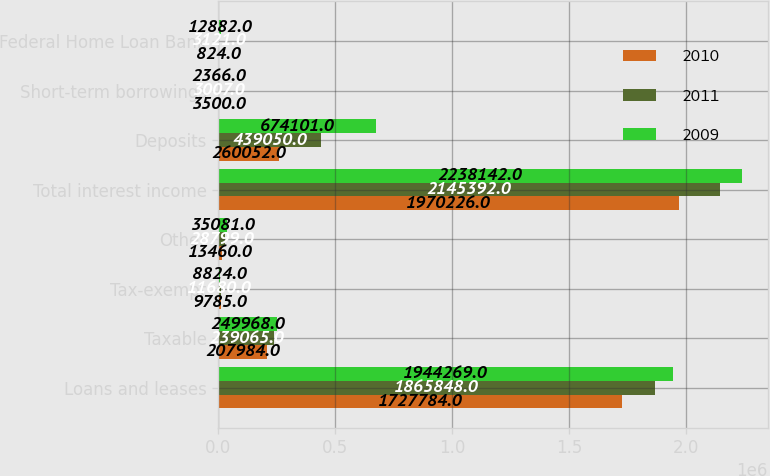Convert chart. <chart><loc_0><loc_0><loc_500><loc_500><stacked_bar_chart><ecel><fcel>Loans and leases<fcel>Taxable<fcel>Tax-exempt<fcel>Other<fcel>Total interest income<fcel>Deposits<fcel>Short-term borrowings<fcel>Federal Home Loan Bank<nl><fcel>2010<fcel>1.72778e+06<fcel>207984<fcel>9785<fcel>13460<fcel>1.97023e+06<fcel>260052<fcel>3500<fcel>824<nl><fcel>2011<fcel>1.86585e+06<fcel>239065<fcel>11680<fcel>28799<fcel>2.14539e+06<fcel>439050<fcel>3007<fcel>3121<nl><fcel>2009<fcel>1.94427e+06<fcel>249968<fcel>8824<fcel>35081<fcel>2.23814e+06<fcel>674101<fcel>2366<fcel>12882<nl></chart> 